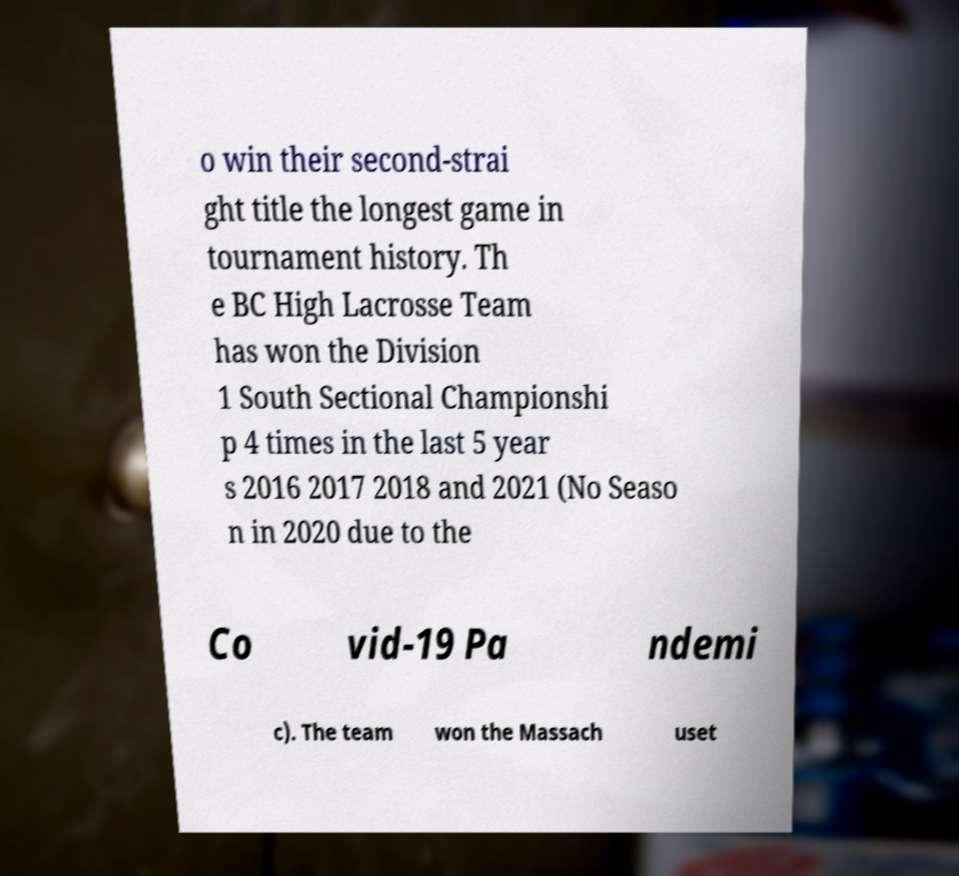What messages or text are displayed in this image? I need them in a readable, typed format. o win their second-strai ght title the longest game in tournament history. Th e BC High Lacrosse Team has won the Division 1 South Sectional Championshi p 4 times in the last 5 year s 2016 2017 2018 and 2021 (No Seaso n in 2020 due to the Co vid-19 Pa ndemi c). The team won the Massach uset 